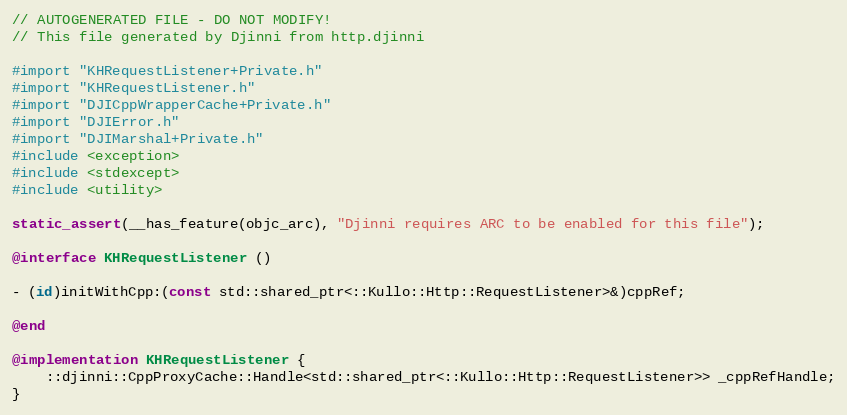<code> <loc_0><loc_0><loc_500><loc_500><_ObjectiveC_>// AUTOGENERATED FILE - DO NOT MODIFY!
// This file generated by Djinni from http.djinni

#import "KHRequestListener+Private.h"
#import "KHRequestListener.h"
#import "DJICppWrapperCache+Private.h"
#import "DJIError.h"
#import "DJIMarshal+Private.h"
#include <exception>
#include <stdexcept>
#include <utility>

static_assert(__has_feature(objc_arc), "Djinni requires ARC to be enabled for this file");

@interface KHRequestListener ()

- (id)initWithCpp:(const std::shared_ptr<::Kullo::Http::RequestListener>&)cppRef;

@end

@implementation KHRequestListener {
    ::djinni::CppProxyCache::Handle<std::shared_ptr<::Kullo::Http::RequestListener>> _cppRefHandle;
}
</code> 